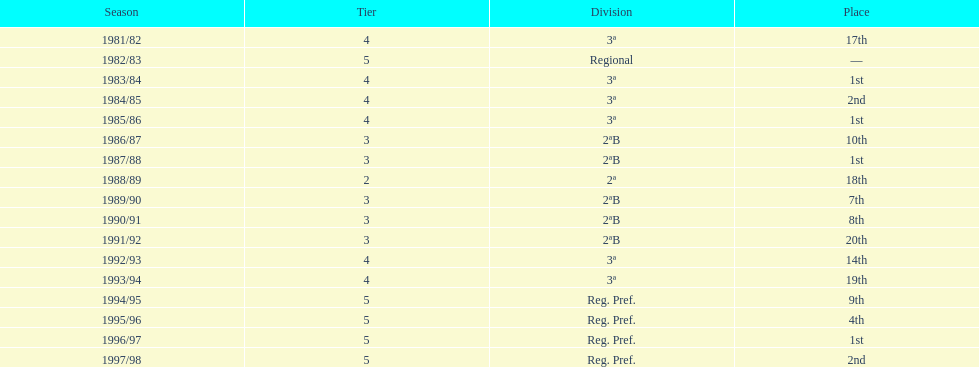What were the number of times second place was earned? 2. 